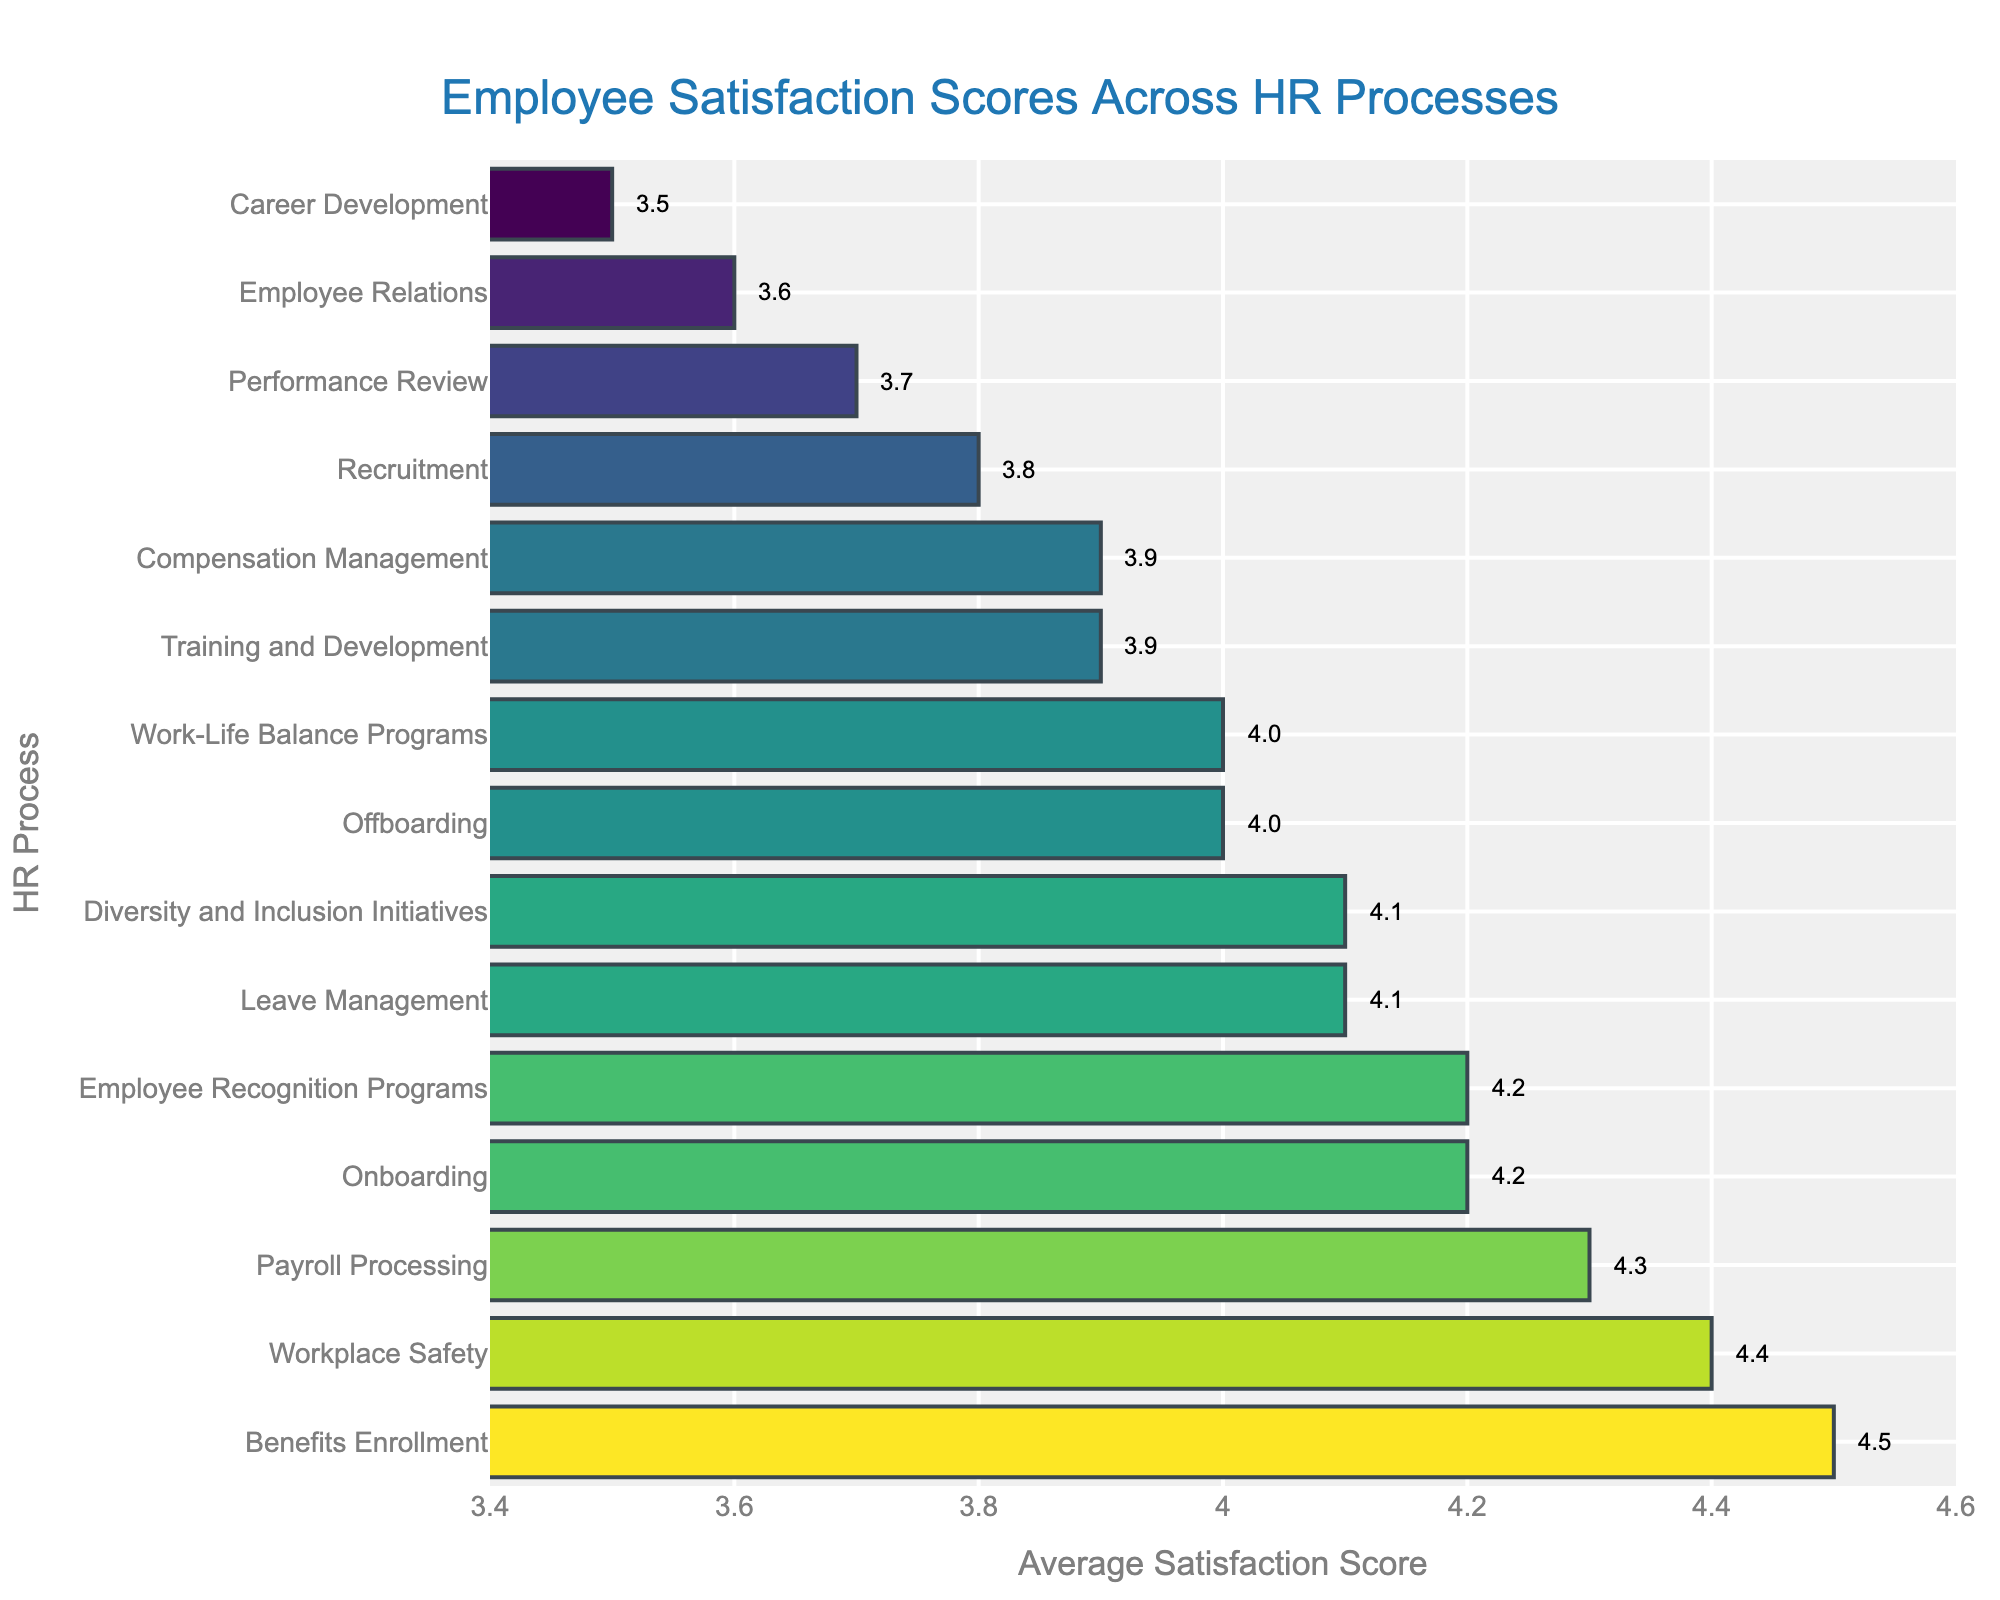What HR process has the highest average satisfaction score? The highest bar on the chart, which represents the HR process with the highest average satisfaction score, corresponds to Benefits Enrollment.
Answer: Benefits Enrollment Which HR process has the lowest average satisfaction score? The lowest bar on the chart, which represents the HR process with the lowest average satisfaction score, corresponds to Career Development.
Answer: Career Development What is the difference in average satisfaction scores between the highest and lowest scoring HR processes? The average satisfaction score for Benefits Enrollment is 4.5, and for Career Development, it is 3.5. The difference is 4.5 - 3.5.
Answer: 1.0 How many HR processes have an average satisfaction score of 4.0 or higher? Count the number of bars that have a value of 4.0 or higher. These processes are Onboarding, Benefits Enrollment, Leave Management, Payroll Processing, Workplace Safety, Diversity and Inclusion Initiatives, and Employee Recognition Programs.
Answer: 7 Which HR processes have a higher average satisfaction score than Performance Review? Identify the bars with a satisfaction score greater than 3.7. These processes include Onboarding, Benefits Enrollment, Leave Management, Payroll Processing, Training and Development, Recruitment, Offboarding, Workplace Safety, Diversity and Inclusion Initiatives, Employee Recognition Programs, and Work-Life Balance Programs.
Answer: 11 What is the total average satisfaction score for all HR processes combined? Sum all the average satisfaction scores from each HR process: 4.2 + 3.7 + 4.5 + 4.1 + 3.9 + 4.3 + 3.8 + 3.6 + 4.0 + 3.5 + 4.4 + 3.9 + 4.1 + 4.2 + 4.0.
Answer: 61.2 What is the average satisfaction score for the HR processes listed? The total average satisfaction score is 61.2 for 15 processes. Divide the total by the number of processes: 61.2 / 15.
Answer: 4.08 Which two HR processes have average satisfaction scores that are closest to each other? Observe the closely positioned bars with almost the same values. Recruitment (3.8) and Employee Relations (3.6) as well as Diversity and Inclusion Initiatives (4.1) and Leave Management (4.1) seem close, but Employee Relations and Career Development (3.6 and 3.5) are the closest with a 0.1 difference.
Answer: Employee Relations and Career Development 